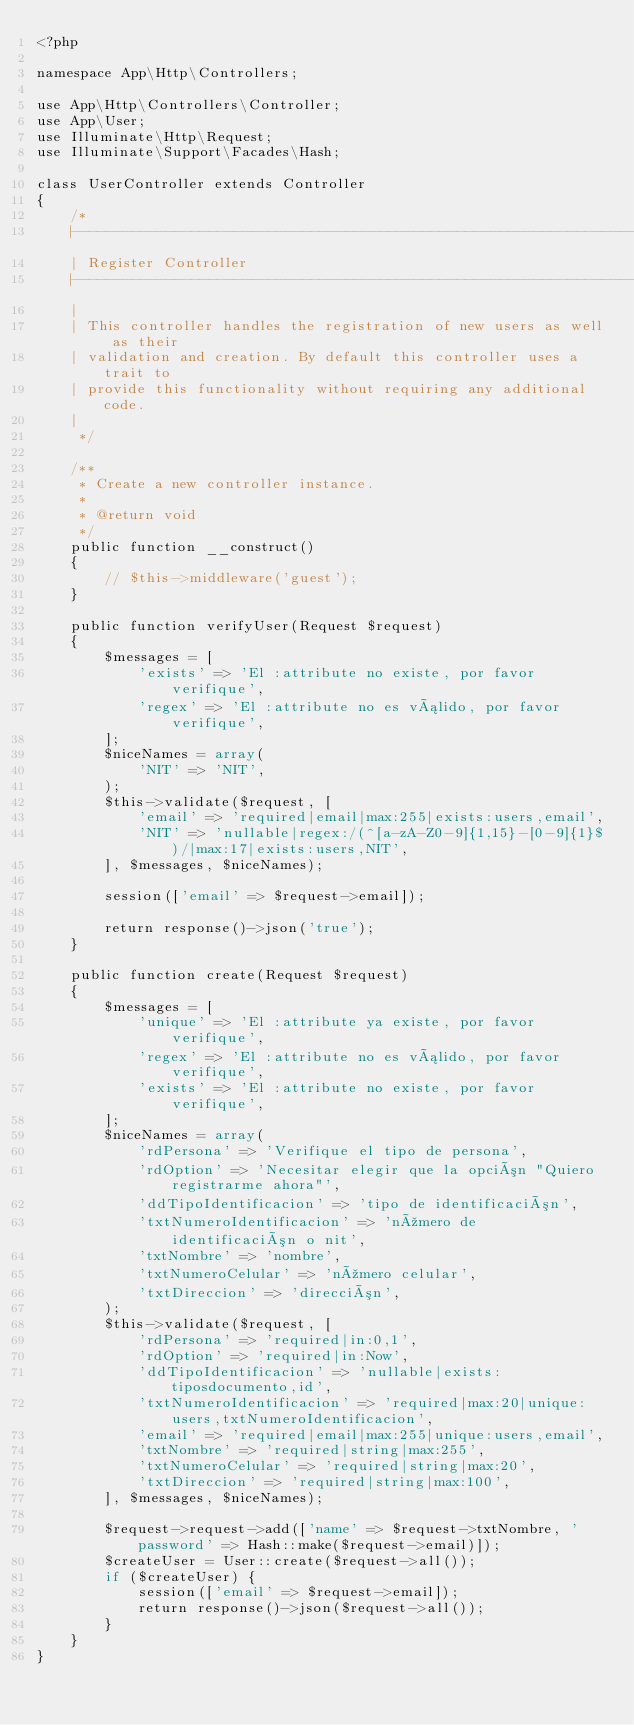<code> <loc_0><loc_0><loc_500><loc_500><_PHP_><?php

namespace App\Http\Controllers;

use App\Http\Controllers\Controller;
use App\User;
use Illuminate\Http\Request;
use Illuminate\Support\Facades\Hash;

class UserController extends Controller
{
    /*
    |--------------------------------------------------------------------------
    | Register Controller
    |--------------------------------------------------------------------------
    |
    | This controller handles the registration of new users as well as their
    | validation and creation. By default this controller uses a trait to
    | provide this functionality without requiring any additional code.
    |
     */

    /**
     * Create a new controller instance.
     *
     * @return void
     */
    public function __construct()
    {
        // $this->middleware('guest');
    }

    public function verifyUser(Request $request)
    {
        $messages = [
            'exists' => 'El :attribute no existe, por favor verifique',
            'regex' => 'El :attribute no es válido, por favor verifique',
        ];
        $niceNames = array(
            'NIT' => 'NIT',
        );
        $this->validate($request, [
            'email' => 'required|email|max:255|exists:users,email',
            'NIT' => 'nullable|regex:/(^[a-zA-Z0-9]{1,15}-[0-9]{1}$)/|max:17|exists:users,NIT',
        ], $messages, $niceNames);

        session(['email' => $request->email]);

        return response()->json('true');
    }

    public function create(Request $request)
    {
        $messages = [
            'unique' => 'El :attribute ya existe, por favor verifique',
            'regex' => 'El :attribute no es válido, por favor verifique',
            'exists' => 'El :attribute no existe, por favor verifique',
        ];
        $niceNames = array(
            'rdPersona' => 'Verifique el tipo de persona',
            'rdOption' => 'Necesitar elegir que la opción "Quiero registrarme ahora"',
            'ddTipoIdentificacion' => 'tipo de identificación',
            'txtNumeroIdentificacion' => 'número de identificación o nit',
            'txtNombre' => 'nombre',
            'txtNumeroCelular' => 'número celular',
            'txtDireccion' => 'dirección',
        );
        $this->validate($request, [
            'rdPersona' => 'required|in:0,1',
            'rdOption' => 'required|in:Now',
            'ddTipoIdentificacion' => 'nullable|exists:tiposdocumento,id',
            'txtNumeroIdentificacion' => 'required|max:20|unique:users,txtNumeroIdentificacion',
            'email' => 'required|email|max:255|unique:users,email',
            'txtNombre' => 'required|string|max:255',
            'txtNumeroCelular' => 'required|string|max:20',
            'txtDireccion' => 'required|string|max:100',
        ], $messages, $niceNames);

        $request->request->add(['name' => $request->txtNombre, 'password' => Hash::make($request->email)]);
        $createUser = User::create($request->all());
        if ($createUser) {
            session(['email' => $request->email]);
            return response()->json($request->all());
        }
    }
}
</code> 